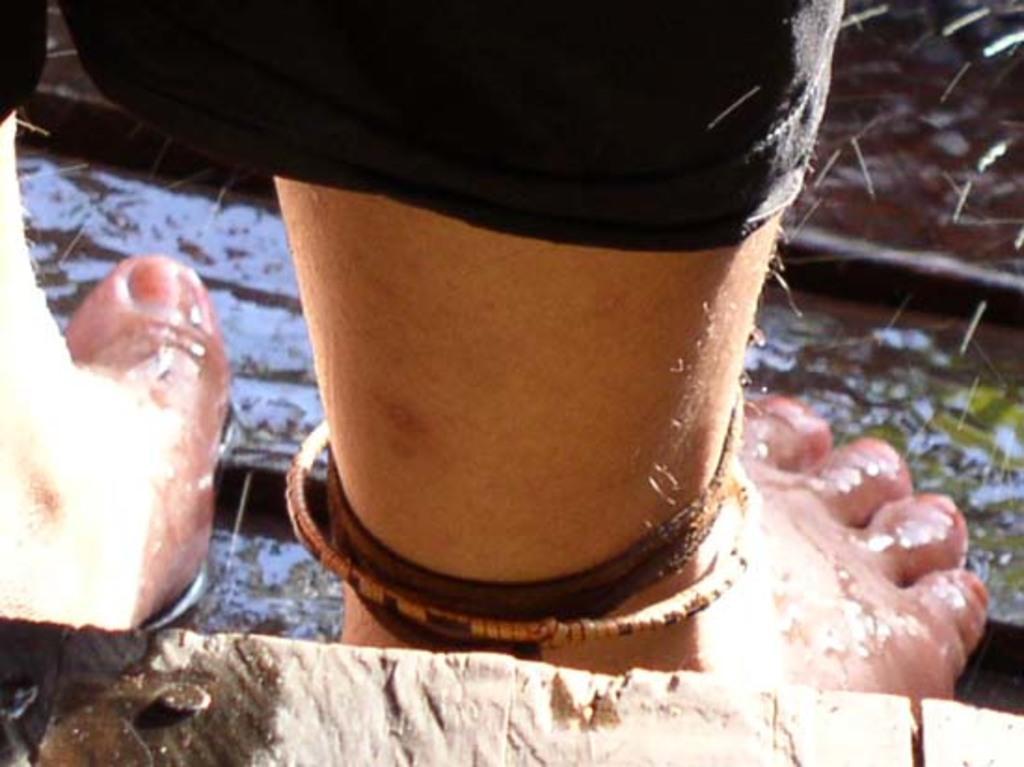How would you summarize this image in a sentence or two? In this image we can see legs of a person and there is water. 